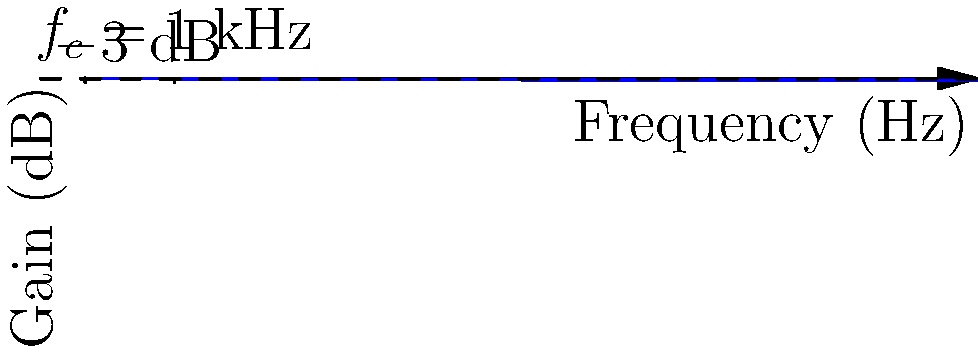Consider a low-pass RC filter circuit with $R = 1.59$ kΩ and $C = 100$ nF. Based on the frequency response graph shown, determine the cutoff frequency $f_c$ of the filter. How does this relate to the time constant $\tau$ of the RC circuit? To solve this problem, let's follow these steps:

1) The cutoff frequency $f_c$ of a low-pass RC filter is the frequency at which the output voltage is 70.7% of the input voltage, or equivalently, where the gain is -3 dB.

2) From the graph, we can see that the -3 dB point occurs at 1 kHz. Therefore, $f_c = 1$ kHz.

3) The cutoff frequency of an RC low-pass filter is given by the formula:

   $$f_c = \frac{1}{2\pi RC}$$

4) We can verify this with the given component values:

   $$f_c = \frac{1}{2\pi (1.59 \times 10^3)(100 \times 10^{-9})} \approx 1000 \text{ Hz} = 1 \text{ kHz}$$

5) The time constant $\tau$ of an RC circuit is given by:

   $$\tau = RC$$

6) For this circuit:

   $$\tau = (1.59 \times 10^3)(100 \times 10^{-9}) = 159 \text{ μs}$$

7) The relationship between $f_c$ and $\tau$ is:

   $$f_c = \frac{1}{2\pi \tau}$$

This relationship shows that the cutoff frequency is inversely proportional to the time constant of the RC circuit.
Answer: $f_c = 1$ kHz; $\tau = 159$ μs; $f_c = \frac{1}{2\pi \tau}$ 